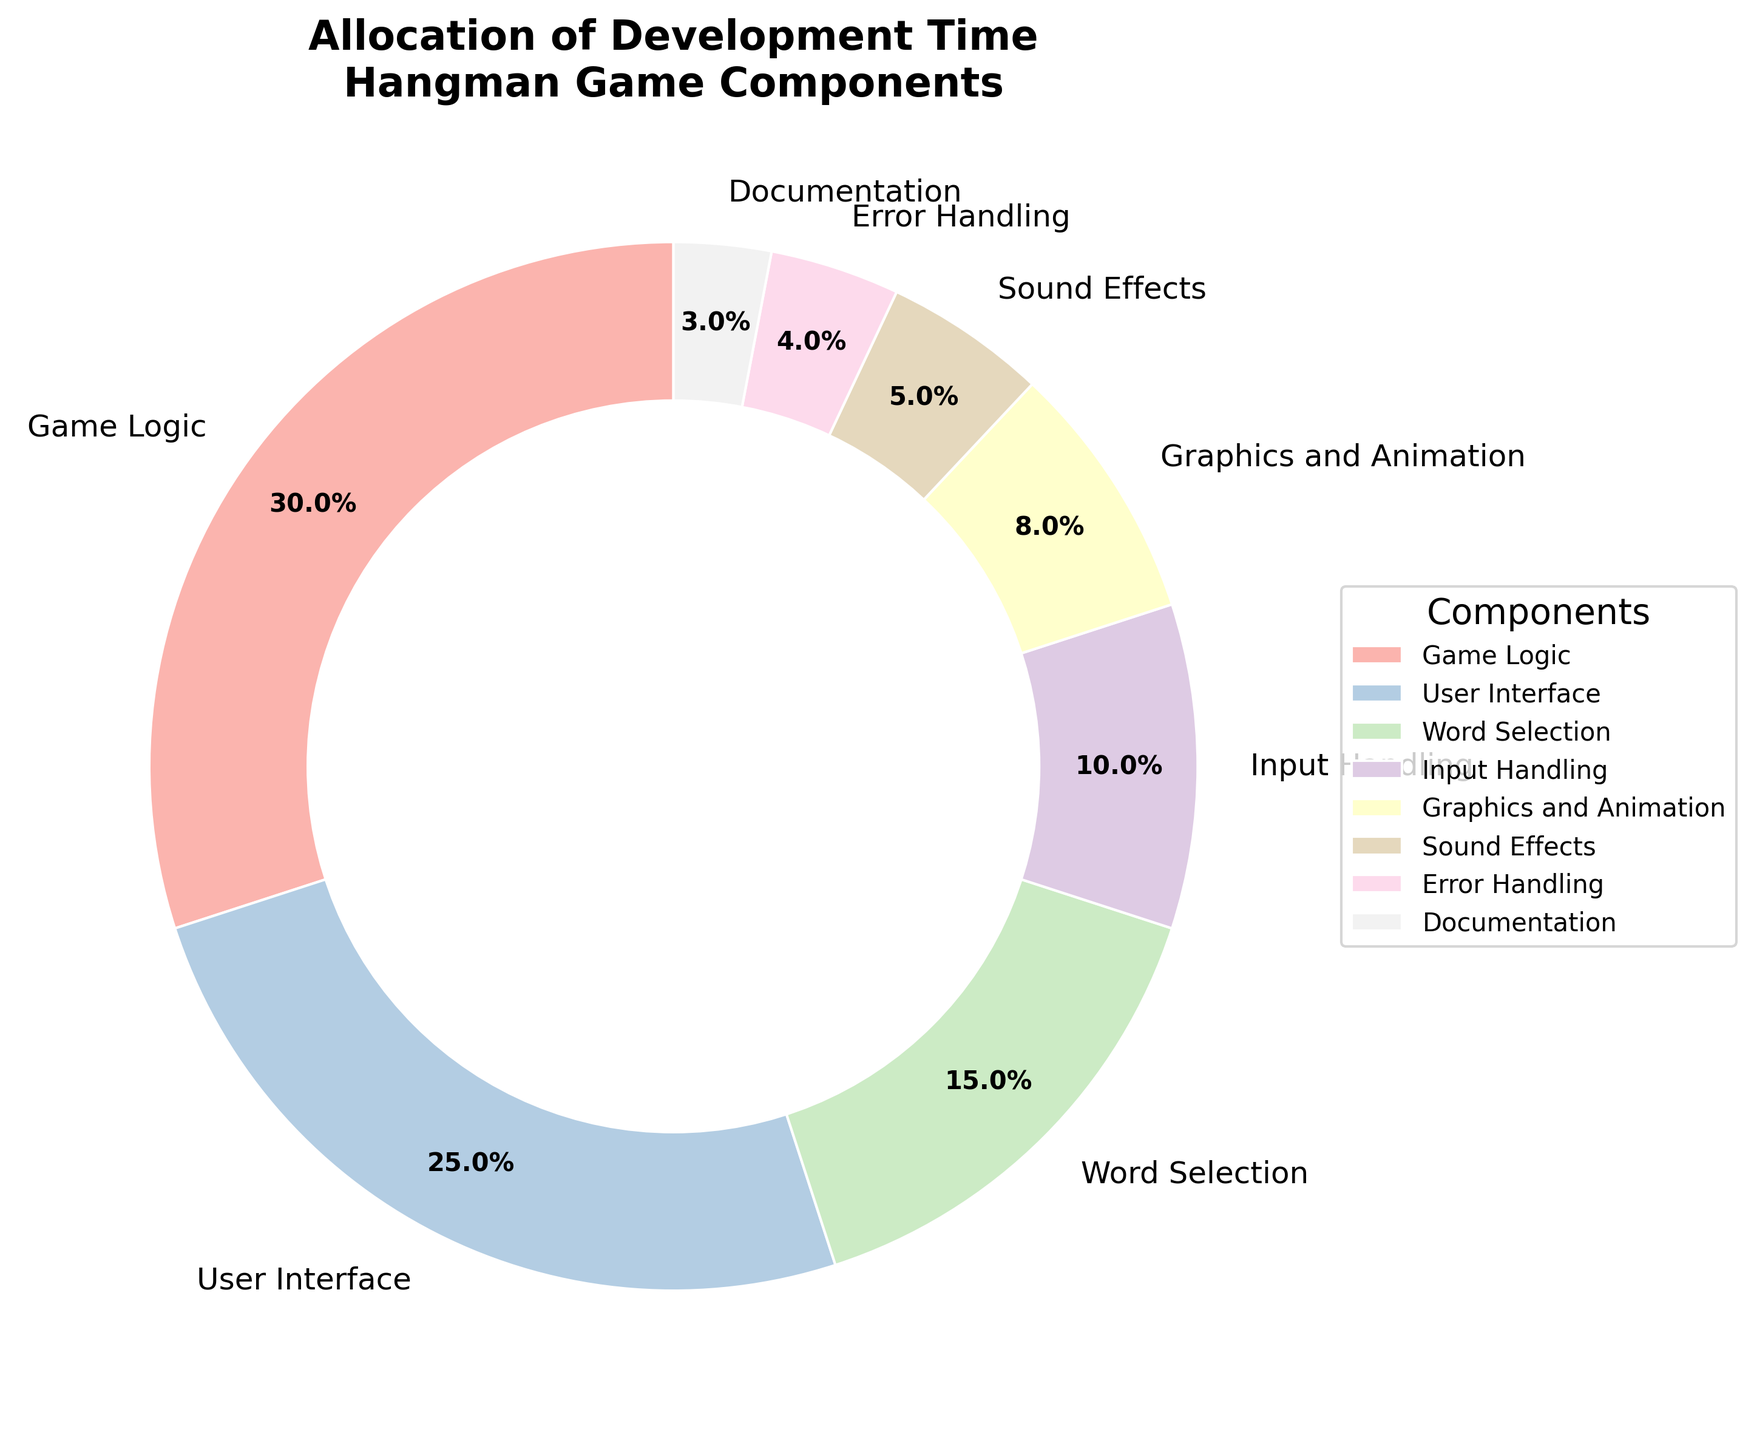What component takes the largest share of development time? The pie chart shows different components and their corresponding percentages. The component with the highest percentage is "Game Logic" at 30%.
Answer: Game Logic How much more development time is allocated to the User Interface compared to Input Handling? The User Interface takes 25% and Input Handling takes 10%. To find the difference, subtract 10% from 25%.
Answer: 15% If we combine the development time for Word Selection and Sound Effects, what percentage of the total development time do they represent? Word Selection is 15% and Sound Effects is 5%. Adding these two gives 15% + 5% = 20%.
Answer: 20% Which two components together make up more than half of the development time? The largest two sectors are Game Logic (30%) and User Interface (25%). Adding them together, 30% + 25% = 55%, which is more than half.
Answer: Game Logic and User Interface Is the percentage of development time allocated to Error Handling greater than, less than, or equal to that for Sound Effects? Error Handling is 4% and Sound Effects is 5%. Comparing these percentages shows that 4% is less than 5%.
Answer: Less than How many components take up less than 10% of the total development time individually? The components with less than 10% are Input Handling (10%), Graphics and Animation (8%), Sound Effects (5%), Error Handling (4%), and Documentation (3%). Except Input Handling, the count is four: Graphics and Animation, Sound Effects, Error Handling, and Documentation.
Answer: 4 What is the total percentage of development time dedicated to the Sound Effects and Documentation combined? Sound Effects is 5% and Documentation is 3%. Adding these together results in 5% + 3% = 8%.
Answer: 8% Which component is represented by the lightest color in the chart? The colors used in the pie chart are varying shades. The lightest shade corresponds to the section labeled "Documentation".
Answer: Documentation Is the combined percentage of development time for Graphics and Animation and User Interface greater than the time allocated to Game Logic? Graphics and Animation is 8% and User Interface is 25%. Adding these together gives 8% + 25% = 33%, which is greater than Game Logic's 30%.
Answer: Yes Which component has the smallest share of development time? The pie chart shows several components with their percentages, where "Documentation" is the smallest at 3%.
Answer: Documentation 